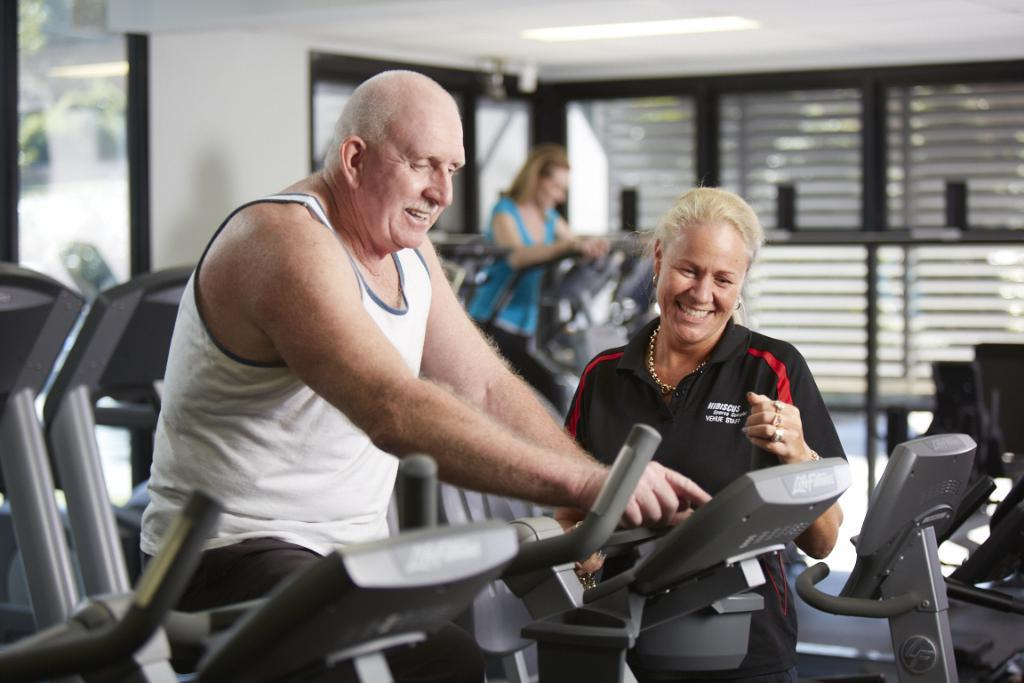How many people are in the image? There are two persons in the image. What are the persons in the image doing? Both persons are cycling. Can you describe the clothing of one of the persons? One person is wearing a white T-shirt. What is the gender of one of the persons in the image? There is a woman in the image. What can be seen in the background of the image? There is a door visible in the background of the image. What type of trousers is the woman wearing in the image? The provided facts do not mention the type of trousers the woman is wearing in the image. --- Facts: 1. There is a car in the image. 2. The car is red. 3. The car has four wheels. 4. There is a road in the image. 5. The road is paved. Absurd Topics: bird, ocean, mountain Conversation: What is the main subject of the image? The main subject of the image is a car. What color is the car? The car is red. How many wheels does the car have? The car has four wheels. What can be seen in the background of the image? There is a road in the image. What is the condition of the road? The road is paved. Reasoning: Let's think step by step in order to produce the conversation. We start by identifying the main subject of the image, which is the car. Then, we describe the car's color and the number of wheels it has. Next, we provide details about the background of the image, mentioning the presence of a road. Finally, we describe the condition of the road, stating that it is paved. Absurd Question/Answer: Can you see any mountains in the image? There are no mountains present in the image; it features a red car and a paved road. 